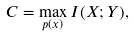<formula> <loc_0><loc_0><loc_500><loc_500>C = \max _ { p ( x ) } I ( X ; Y ) ,</formula> 